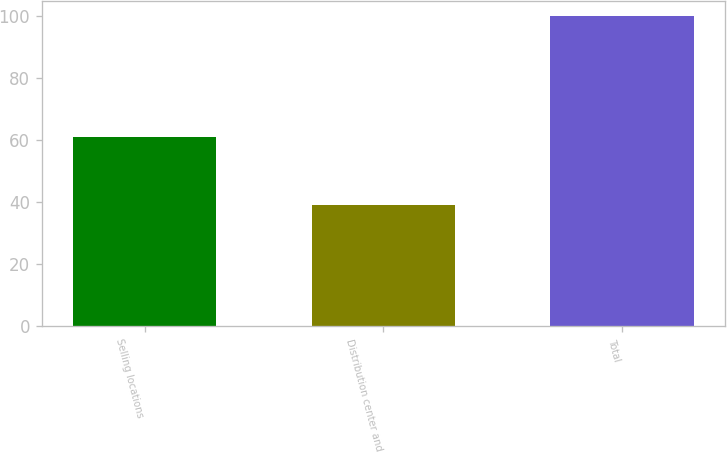Convert chart to OTSL. <chart><loc_0><loc_0><loc_500><loc_500><bar_chart><fcel>Selling locations<fcel>Distribution center and<fcel>Total<nl><fcel>61<fcel>39<fcel>100<nl></chart> 